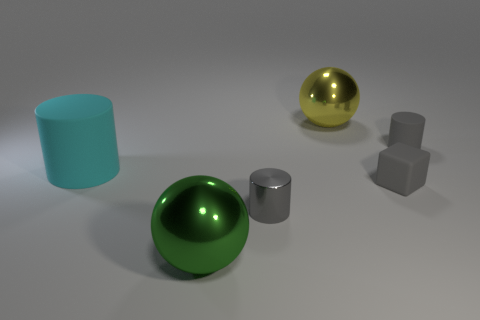How many other cubes are the same color as the tiny cube?
Give a very brief answer. 0. How many objects are there?
Your answer should be compact. 6. How many small gray objects have the same material as the gray block?
Keep it short and to the point. 1. There is a green shiny thing that is the same shape as the yellow metal thing; what size is it?
Ensure brevity in your answer.  Large. What is the material of the cyan object?
Keep it short and to the point. Rubber. What material is the big thing on the left side of the metallic ball that is to the left of the large yellow shiny sphere behind the gray matte cube?
Keep it short and to the point. Rubber. Are there any other things that are the same shape as the green metal thing?
Make the answer very short. Yes. There is a shiny object that is the same shape as the large rubber object; what color is it?
Provide a short and direct response. Gray. Do the big rubber cylinder that is in front of the large yellow ball and the sphere that is on the right side of the big green metal thing have the same color?
Provide a succinct answer. No. Are there more small matte blocks to the left of the green shiny ball than gray cylinders?
Your answer should be compact. No. 